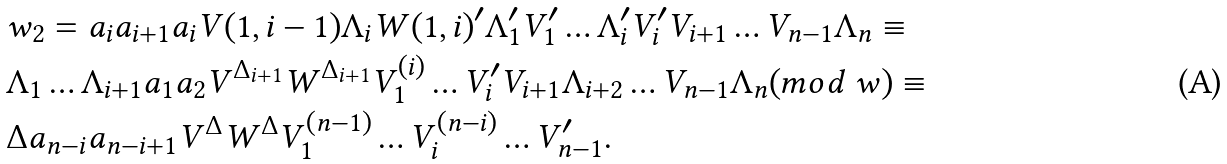<formula> <loc_0><loc_0><loc_500><loc_500>& w _ { 2 } = a _ { i } a _ { i + 1 } a _ { i } V ( 1 , i - 1 ) \Lambda _ { i } W ( 1 , i ) ^ { \prime } \Lambda _ { 1 } ^ { \prime } V _ { 1 } ^ { \prime } \dots \Lambda _ { i } ^ { \prime } V _ { i } ^ { \prime } V _ { i + 1 } \dots V _ { n - 1 } \Lambda _ { n } \equiv \\ & \Lambda _ { 1 } \dots \Lambda _ { i + 1 } a _ { 1 } a _ { 2 } V ^ { \Delta _ { i + 1 } } W ^ { \Delta _ { i + 1 } } V _ { 1 } ^ { ( i ) } \dots V _ { i } ^ { \prime } V _ { i + 1 } \Lambda _ { i + 2 } \dots V _ { n - 1 } \Lambda _ { n } ( m o d \ w ) \equiv \\ & \Delta a _ { n - i } a _ { n - i + 1 } V ^ { \Delta } W ^ { \Delta } V _ { 1 } ^ { ( n - 1 ) } \dots V _ { i } ^ { ( n - i ) } \dots V _ { n - 1 } ^ { \prime } . \\</formula> 